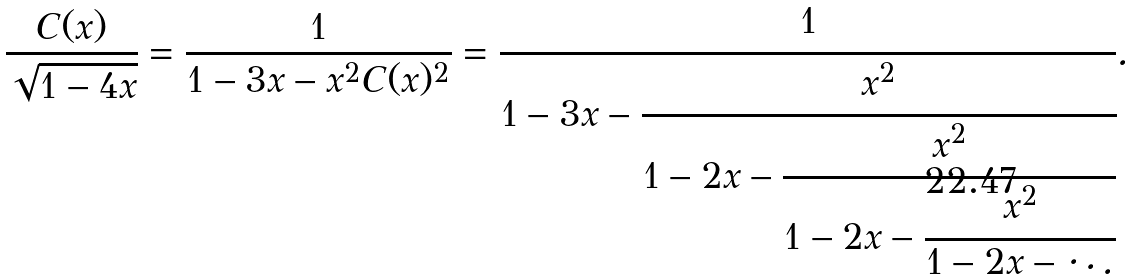<formula> <loc_0><loc_0><loc_500><loc_500>\frac { C ( x ) } { \sqrt { 1 - 4 x } } = \frac { 1 } { 1 - 3 x - x ^ { 2 } C ( x ) ^ { 2 } } = \cfrac { 1 } { 1 - 3 x - \cfrac { x ^ { 2 } } { 1 - 2 x - \cfrac { x ^ { 2 } } { 1 - 2 x - \cfrac { x ^ { 2 } } { 1 - 2 x - \ddots } } } } .</formula> 